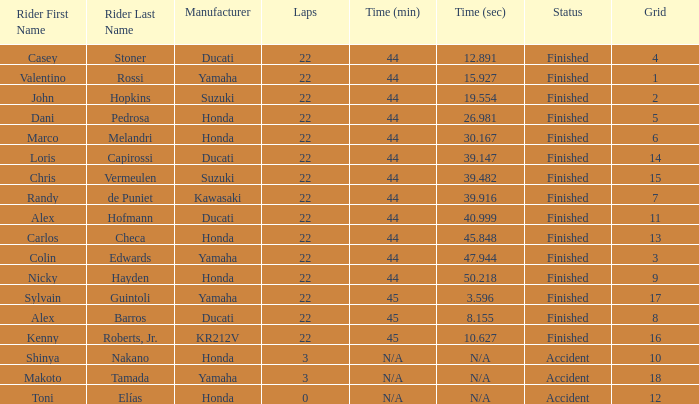Can you give me this table as a dict? {'header': ['Rider First Name', 'Rider Last Name', 'Manufacturer', 'Laps', 'Time (min)', 'Time (sec)', 'Status', 'Grid'], 'rows': [['Casey', 'Stoner', 'Ducati', '22', '44', '12.891', 'Finished', '4'], ['Valentino', 'Rossi', 'Yamaha', '22', '44', '15.927', 'Finished', '1'], ['John', 'Hopkins', 'Suzuki', '22', '44', '19.554', 'Finished', '2'], ['Dani', 'Pedrosa', 'Honda', '22', '44', '26.981', 'Finished', '5'], ['Marco', 'Melandri', 'Honda', '22', '44', '30.167', 'Finished', '6'], ['Loris', 'Capirossi', 'Ducati', '22', '44', '39.147', 'Finished', '14'], ['Chris', 'Vermeulen', 'Suzuki', '22', '44', '39.482', 'Finished', '15'], ['Randy', 'de Puniet', 'Kawasaki', '22', '44', '39.916', 'Finished', '7'], ['Alex', 'Hofmann', 'Ducati', '22', '44', '40.999', 'Finished', '11'], ['Carlos', 'Checa', 'Honda', '22', '44', '45.848', 'Finished', '13'], ['Colin', 'Edwards', 'Yamaha', '22', '44', '47.944', 'Finished', '3'], ['Nicky', 'Hayden', 'Honda', '22', '44', '50.218', 'Finished', '9'], ['Sylvain', 'Guintoli', 'Yamaha', '22', '45', '3.596', 'Finished', '17'], ['Alex', 'Barros', 'Ducati', '22', '45', '8.155', 'Finished', '8'], ['Kenny', 'Roberts, Jr.', 'KR212V', '22', '45', '10.627', 'Finished', '16'], ['Shinya', 'Nakano', 'Honda', '3', 'N/A', 'N/A', 'Accident', '10'], ['Makoto', 'Tamada', 'Yamaha', '3', 'N/A', 'N/A', 'Accident', '18'], ['Toni', 'Elías', 'Honda', '0', 'N/A', 'N/A', 'Accident', '12']]} What is the average grid for competitors who had more than 22 laps and time/retired of +17.276? None. 